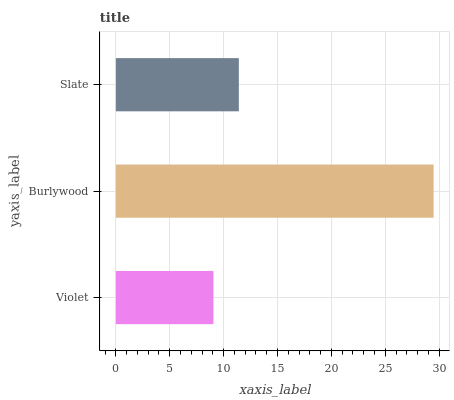Is Violet the minimum?
Answer yes or no. Yes. Is Burlywood the maximum?
Answer yes or no. Yes. Is Slate the minimum?
Answer yes or no. No. Is Slate the maximum?
Answer yes or no. No. Is Burlywood greater than Slate?
Answer yes or no. Yes. Is Slate less than Burlywood?
Answer yes or no. Yes. Is Slate greater than Burlywood?
Answer yes or no. No. Is Burlywood less than Slate?
Answer yes or no. No. Is Slate the high median?
Answer yes or no. Yes. Is Slate the low median?
Answer yes or no. Yes. Is Burlywood the high median?
Answer yes or no. No. Is Burlywood the low median?
Answer yes or no. No. 